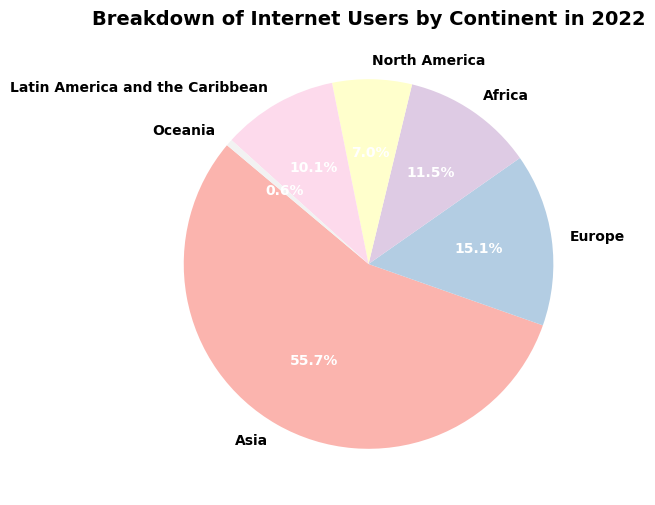What percentage of internet users are in Asia? Look directly at the pie chart slice labeled "Asia" to find its associated percentage.
Answer: 61.6% How many more internet users are there in Europe compared to Oceania? Find the number of users in Europe (743 million) and Oceania (29 million), then subtract the smaller number from the larger one: 743 - 29 = 714.
Answer: 714 million Which continent has the least number of internet users, and what percentage does it represent? Identify the smallest pie chart slice, which is labeled "Oceania," and read its percentage.
Answer: Oceania, 0.7% Is the number of internet users in Latin America and the Caribbean greater than in North America? Compare the numbers for Latin America and the Caribbean (498 million) and North America (342 million).
Answer: Yes What's the combined percentage of internet users in Africa and Latin America and the Caribbean? Find the individual percentages for Africa (12.7%) and Latin America and the Caribbean (11.2%), then add them together: 12.7% + 11.2% = 23.9%.
Answer: 23.9% What is the difference in the percentage of internet users between Asia and Europe? Subtract the percentage for Europe (16.7%) from the percentage for Asia (61.6%): 61.6% - 16.7% = 44.9%.
Answer: 44.9% Which continent has a higher percentage of internet users, North America or Africa? Compare the percentages for North America (7.7%) and Africa (12.7%).
Answer: Africa What color represents North America in the pie chart? Examine the pie chart and identify the color used for the North America slice.
Answer: [Specific color, depending on the actual pie chart] What is the total number of internet users represented in the pie chart? Sum the number of users from all continents: 2740 + 743 + 565 + 342 + 498 + 29 = 4917 million.
Answer: 4917 million How much larger in percentage terms is the internet user base in Asia compared to that in Europe? Divide the percentage for Asia (61.6%) by the percentage for Europe (16.7%) and then subtract 1 and multiply by 100 to get the percentage difference: (61.6 / 16.7 - 1) * 100 ≈ 269%.
Answer: 269% 